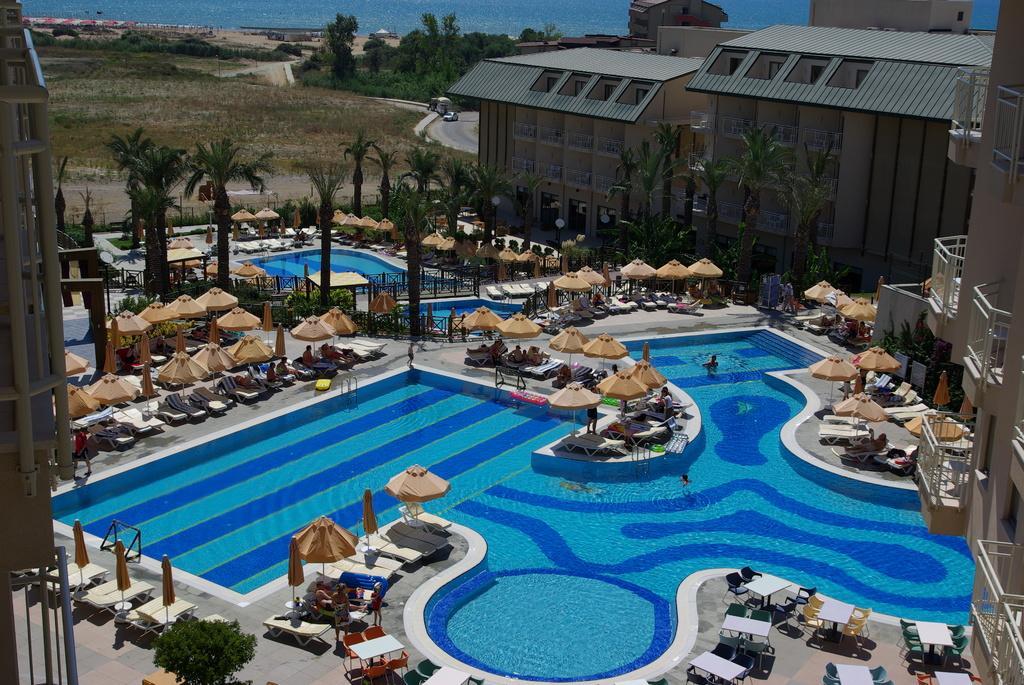How would you summarize this image in a sentence or two? In this picture we can see group of people, swimming pool and few buildings, beside to the swimming pool we can find few umbrellas, chairs and tables, and also we can see few trees and vehicles. 